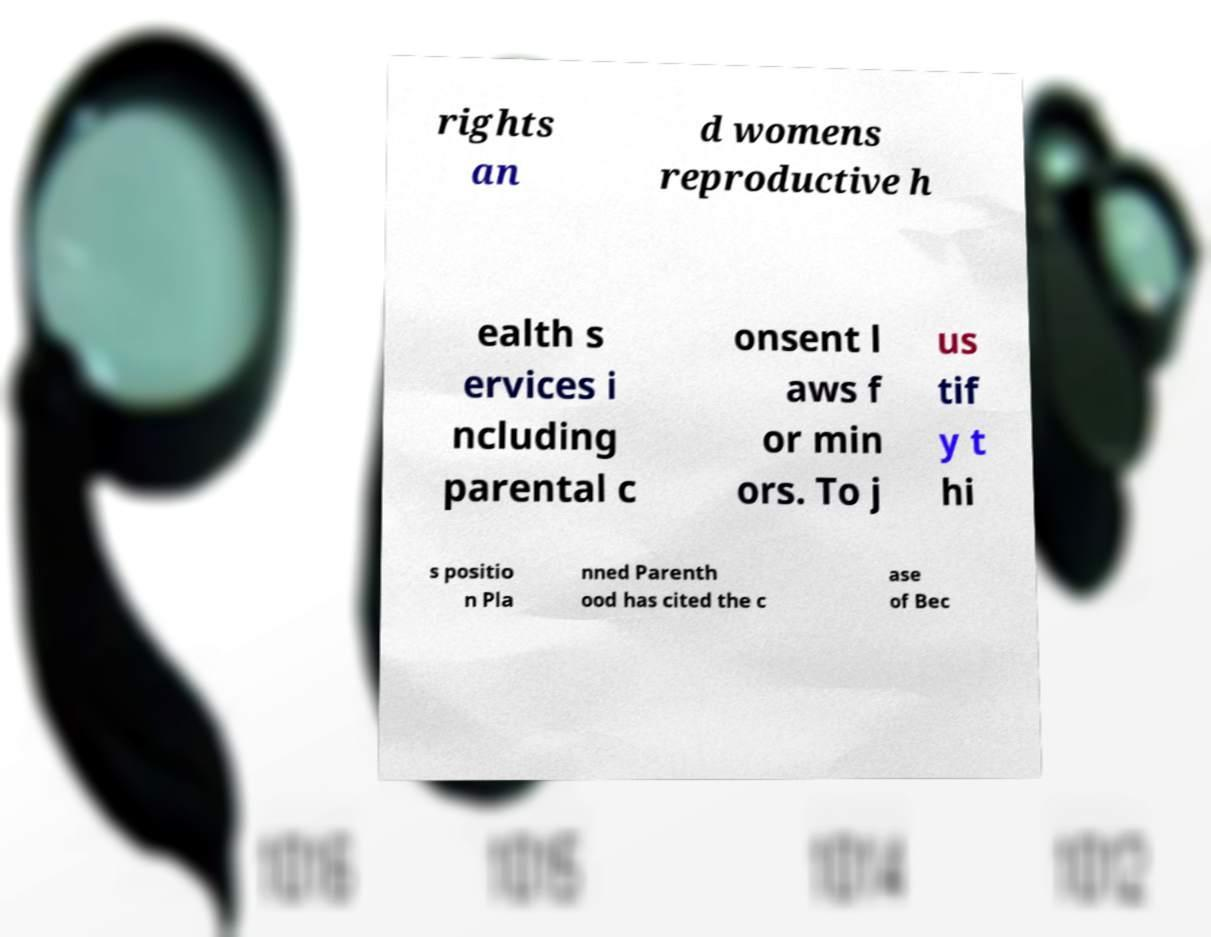What messages or text are displayed in this image? I need them in a readable, typed format. rights an d womens reproductive h ealth s ervices i ncluding parental c onsent l aws f or min ors. To j us tif y t hi s positio n Pla nned Parenth ood has cited the c ase of Bec 